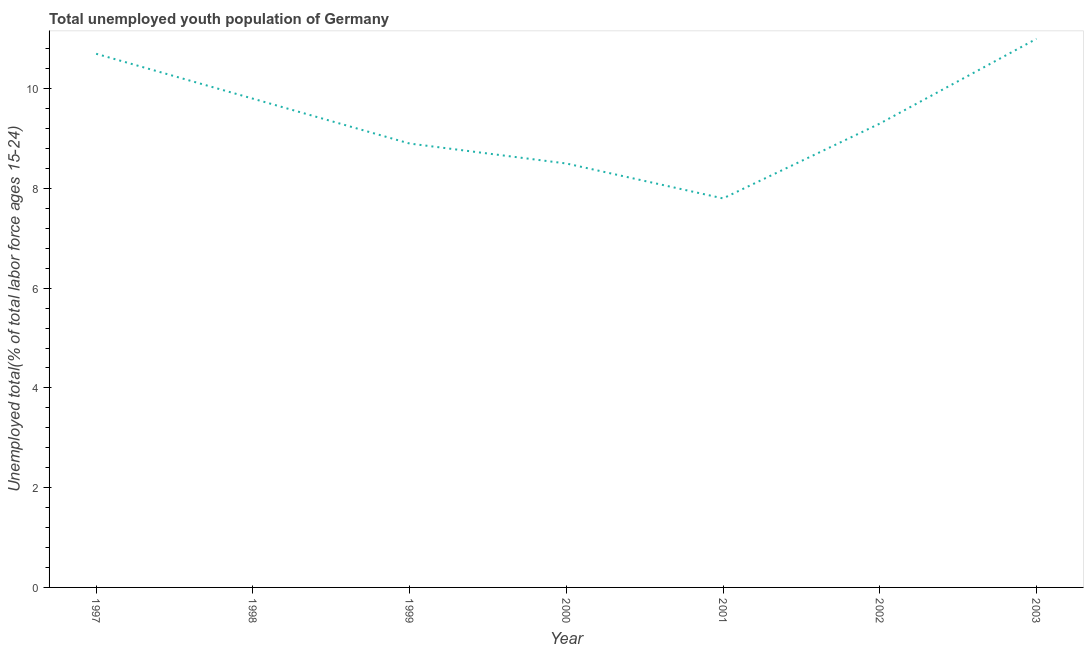What is the unemployed youth in 1999?
Offer a very short reply. 8.9. Across all years, what is the minimum unemployed youth?
Provide a succinct answer. 7.8. In which year was the unemployed youth minimum?
Your response must be concise. 2001. What is the sum of the unemployed youth?
Ensure brevity in your answer.  66. What is the difference between the unemployed youth in 1997 and 2001?
Ensure brevity in your answer.  2.9. What is the average unemployed youth per year?
Offer a very short reply. 9.43. What is the median unemployed youth?
Keep it short and to the point. 9.3. Do a majority of the years between 2000 and 2002 (inclusive) have unemployed youth greater than 3.6 %?
Ensure brevity in your answer.  Yes. What is the ratio of the unemployed youth in 1998 to that in 2002?
Make the answer very short. 1.05. Is the unemployed youth in 1999 less than that in 2000?
Offer a very short reply. No. Is the difference between the unemployed youth in 2002 and 2003 greater than the difference between any two years?
Your response must be concise. No. What is the difference between the highest and the second highest unemployed youth?
Ensure brevity in your answer.  0.3. Is the sum of the unemployed youth in 2001 and 2002 greater than the maximum unemployed youth across all years?
Give a very brief answer. Yes. What is the difference between the highest and the lowest unemployed youth?
Your response must be concise. 3.2. In how many years, is the unemployed youth greater than the average unemployed youth taken over all years?
Provide a short and direct response. 3. How many years are there in the graph?
Offer a very short reply. 7. Are the values on the major ticks of Y-axis written in scientific E-notation?
Offer a very short reply. No. Does the graph contain grids?
Provide a succinct answer. No. What is the title of the graph?
Provide a succinct answer. Total unemployed youth population of Germany. What is the label or title of the Y-axis?
Your answer should be compact. Unemployed total(% of total labor force ages 15-24). What is the Unemployed total(% of total labor force ages 15-24) of 1997?
Offer a terse response. 10.7. What is the Unemployed total(% of total labor force ages 15-24) of 1998?
Offer a terse response. 9.8. What is the Unemployed total(% of total labor force ages 15-24) of 1999?
Ensure brevity in your answer.  8.9. What is the Unemployed total(% of total labor force ages 15-24) in 2001?
Make the answer very short. 7.8. What is the Unemployed total(% of total labor force ages 15-24) in 2002?
Your answer should be very brief. 9.3. What is the Unemployed total(% of total labor force ages 15-24) in 2003?
Provide a succinct answer. 11. What is the difference between the Unemployed total(% of total labor force ages 15-24) in 1997 and 2000?
Your response must be concise. 2.2. What is the difference between the Unemployed total(% of total labor force ages 15-24) in 1998 and 2000?
Your answer should be compact. 1.3. What is the difference between the Unemployed total(% of total labor force ages 15-24) in 1998 and 2003?
Provide a succinct answer. -1.2. What is the difference between the Unemployed total(% of total labor force ages 15-24) in 1999 and 2000?
Make the answer very short. 0.4. What is the difference between the Unemployed total(% of total labor force ages 15-24) in 2000 and 2001?
Your answer should be compact. 0.7. What is the ratio of the Unemployed total(% of total labor force ages 15-24) in 1997 to that in 1998?
Give a very brief answer. 1.09. What is the ratio of the Unemployed total(% of total labor force ages 15-24) in 1997 to that in 1999?
Your answer should be compact. 1.2. What is the ratio of the Unemployed total(% of total labor force ages 15-24) in 1997 to that in 2000?
Keep it short and to the point. 1.26. What is the ratio of the Unemployed total(% of total labor force ages 15-24) in 1997 to that in 2001?
Make the answer very short. 1.37. What is the ratio of the Unemployed total(% of total labor force ages 15-24) in 1997 to that in 2002?
Keep it short and to the point. 1.15. What is the ratio of the Unemployed total(% of total labor force ages 15-24) in 1998 to that in 1999?
Provide a succinct answer. 1.1. What is the ratio of the Unemployed total(% of total labor force ages 15-24) in 1998 to that in 2000?
Provide a succinct answer. 1.15. What is the ratio of the Unemployed total(% of total labor force ages 15-24) in 1998 to that in 2001?
Make the answer very short. 1.26. What is the ratio of the Unemployed total(% of total labor force ages 15-24) in 1998 to that in 2002?
Ensure brevity in your answer.  1.05. What is the ratio of the Unemployed total(% of total labor force ages 15-24) in 1998 to that in 2003?
Give a very brief answer. 0.89. What is the ratio of the Unemployed total(% of total labor force ages 15-24) in 1999 to that in 2000?
Ensure brevity in your answer.  1.05. What is the ratio of the Unemployed total(% of total labor force ages 15-24) in 1999 to that in 2001?
Offer a terse response. 1.14. What is the ratio of the Unemployed total(% of total labor force ages 15-24) in 1999 to that in 2002?
Your answer should be very brief. 0.96. What is the ratio of the Unemployed total(% of total labor force ages 15-24) in 1999 to that in 2003?
Offer a terse response. 0.81. What is the ratio of the Unemployed total(% of total labor force ages 15-24) in 2000 to that in 2001?
Give a very brief answer. 1.09. What is the ratio of the Unemployed total(% of total labor force ages 15-24) in 2000 to that in 2002?
Offer a terse response. 0.91. What is the ratio of the Unemployed total(% of total labor force ages 15-24) in 2000 to that in 2003?
Your response must be concise. 0.77. What is the ratio of the Unemployed total(% of total labor force ages 15-24) in 2001 to that in 2002?
Your answer should be compact. 0.84. What is the ratio of the Unemployed total(% of total labor force ages 15-24) in 2001 to that in 2003?
Offer a very short reply. 0.71. What is the ratio of the Unemployed total(% of total labor force ages 15-24) in 2002 to that in 2003?
Your answer should be compact. 0.84. 